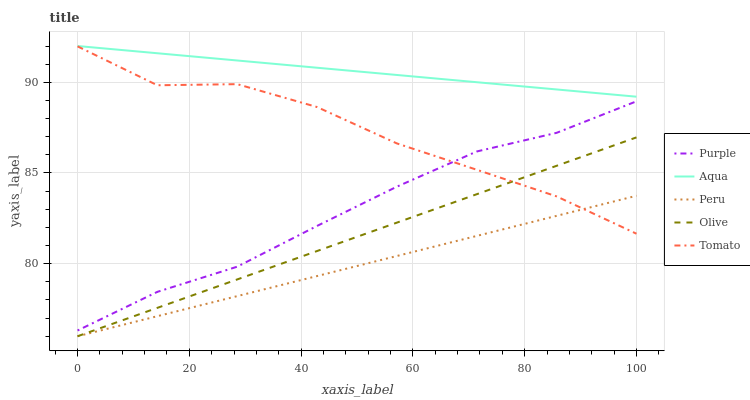Does Peru have the minimum area under the curve?
Answer yes or no. Yes. Does Aqua have the maximum area under the curve?
Answer yes or no. Yes. Does Olive have the minimum area under the curve?
Answer yes or no. No. Does Olive have the maximum area under the curve?
Answer yes or no. No. Is Aqua the smoothest?
Answer yes or no. Yes. Is Tomato the roughest?
Answer yes or no. Yes. Is Olive the smoothest?
Answer yes or no. No. Is Olive the roughest?
Answer yes or no. No. Does Olive have the lowest value?
Answer yes or no. Yes. Does Tomato have the lowest value?
Answer yes or no. No. Does Aqua have the highest value?
Answer yes or no. Yes. Does Olive have the highest value?
Answer yes or no. No. Is Peru less than Purple?
Answer yes or no. Yes. Is Aqua greater than Peru?
Answer yes or no. Yes. Does Peru intersect Olive?
Answer yes or no. Yes. Is Peru less than Olive?
Answer yes or no. No. Is Peru greater than Olive?
Answer yes or no. No. Does Peru intersect Purple?
Answer yes or no. No. 